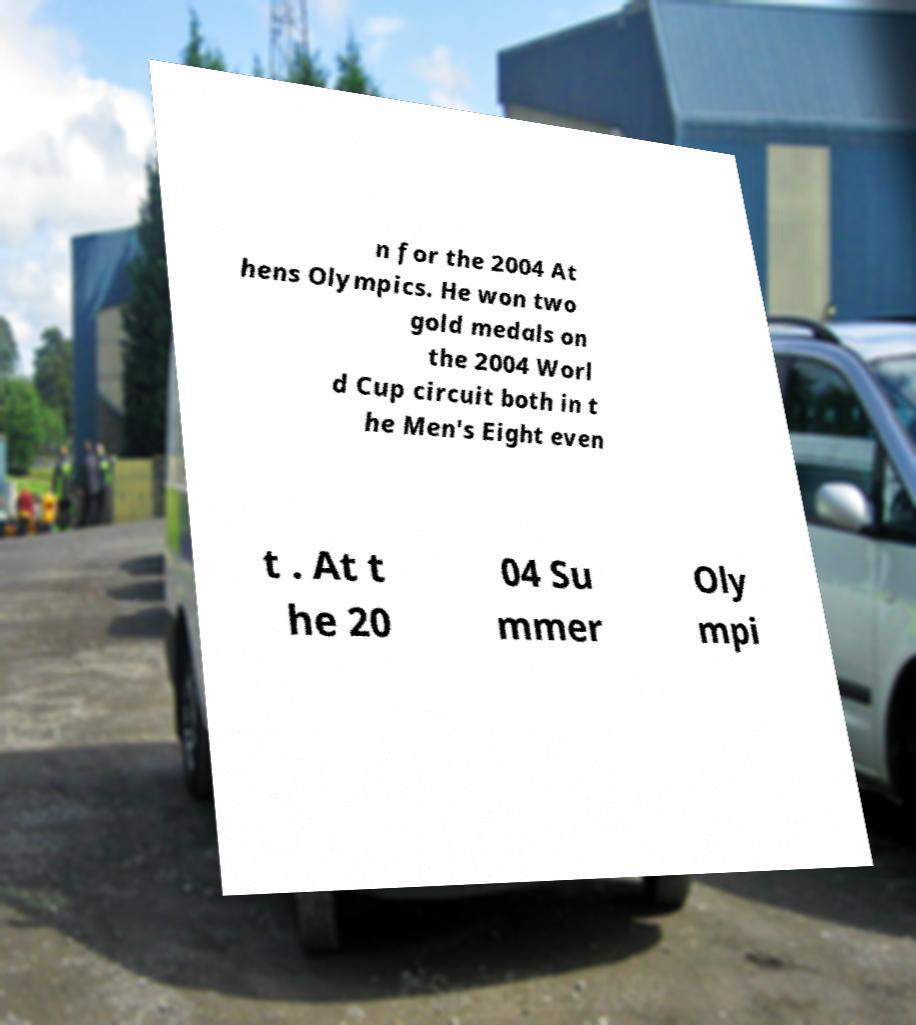Could you assist in decoding the text presented in this image and type it out clearly? n for the 2004 At hens Olympics. He won two gold medals on the 2004 Worl d Cup circuit both in t he Men's Eight even t . At t he 20 04 Su mmer Oly mpi 